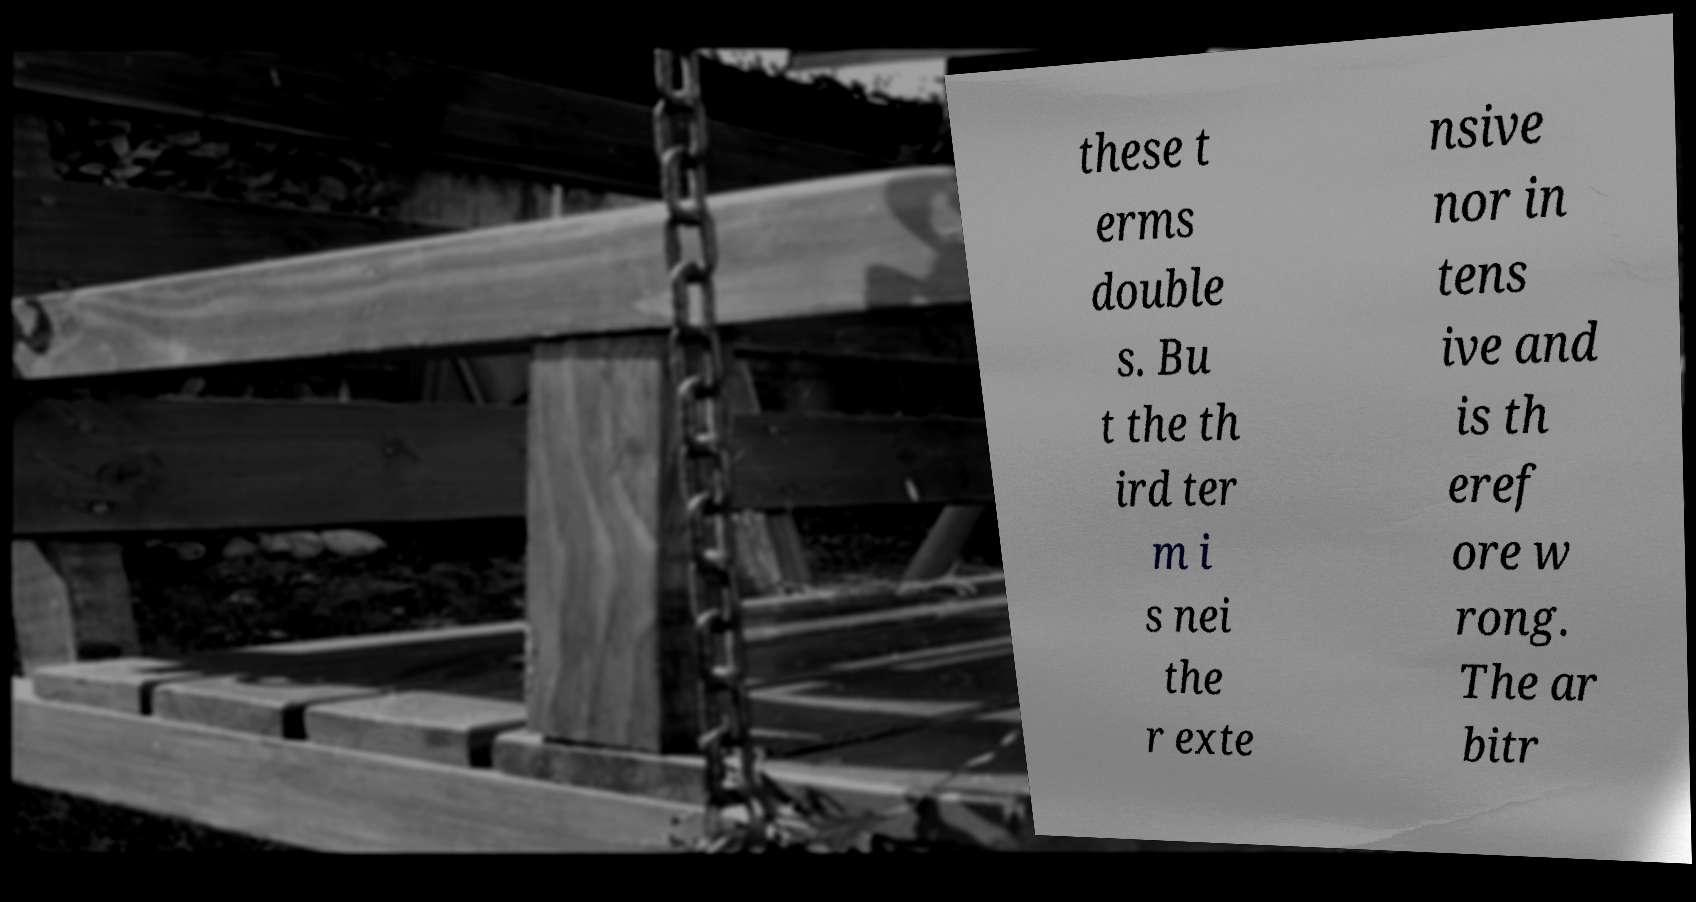There's text embedded in this image that I need extracted. Can you transcribe it verbatim? these t erms double s. Bu t the th ird ter m i s nei the r exte nsive nor in tens ive and is th eref ore w rong. The ar bitr 